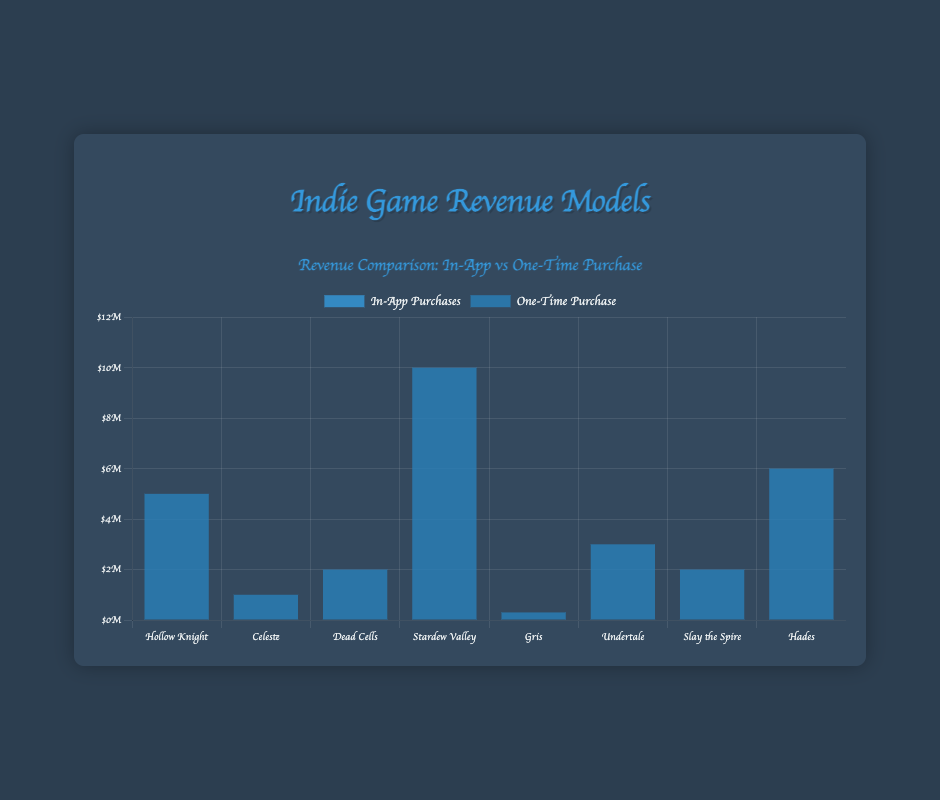Which game generated the highest revenue from one-time purchases? Look at the bars representing "One-Time Purchase" and find the tallest. Stardew Valley has the highest bar representing a revenue of $10,000,000.
Answer: Stardew Valley Which game generated the lowest revenue from one-time purchases? Look at the bars representing "One-Time Purchase" and find the shortest. Gris has the shortest bar representing a revenue of $300,000.
Answer: Gris How much more revenue did Hades generate compared to Celeste from one-time purchases? Look at the respective bars for Hades and Celeste, then subtract Celeste's revenue from Hades'. Hades: $6,000,000, Celeste: $1,000,000. Calculate $6,000,000 - $1,000,000.
Answer: $5,000,000 What’s the total combined revenue from one-time purchases for "Hollow Knight" and "Undertale"? Add the revenue for "Hollow Knight" and "Undertale" by looking at their respective bars. "Hollow Knight" is $5,000,000 and "Undertale" is $3,000,000. Calculate $5,000,000 + $3,000,000.
Answer: $8,000,000 How much more revenue did “Stardew Valley” generate than “Slay the Spire” from one-time purchases? Look at the revenue of "Stardew Valley" and "Slay the Spire" by examining their bars. "Stardew Valley" is at $10,000,000 and "Slay the Spire" is at $2,000,000. Calculate $10,000,000 - $2,000,000.
Answer: $8,000,000 Which revenue model, in-app purchases or one-time purchase, is used exclusively by all the games in the chart? Observe both bars for each game. One-time purchases have non-zero values, while in-app purchases for all games are zero.
Answer: One-time purchase What’s the average revenue from one-time purchases across all listed games? Sum up the revenue for all games from one-time purchases and then divide by the number of games. The total sum is $26,300,000 (sum of all one-time purchase bars). The number of games is 8. Calculate $26,300,000 / 8.
Answer: $3,287,500 Which game generated more revenue, "Dead Cells" or "Undertale"? Compare the height of their bars for one-time purchases. "Dead Cells" is at $2,000,000 and "Undertale" is at $3,000,000.
Answer: Undertale What is the median revenue of the one-time purchases? Arrange the revenues in ascending order and find the middle number or the average of the two middle numbers. The sorted revenues: $300,000, $1,000,000, $2,000,000, $2,000,000, $3,000,000, $5,000,000, $6,000,000, $10,000,000. Middle values are $2,000,000 and $3,000,000. Calculate ($2,000,000 + $3,000,000) / 2.
Answer: $2,500,000 How much more revenue did "Hades" generate compared to the average revenue from one-time purchases? First, find the average revenue ($3,287,500). Hades's revenue is $6,000,000. Calculate $6,000,000 - $3,287,500.
Answer: $2,712,500 